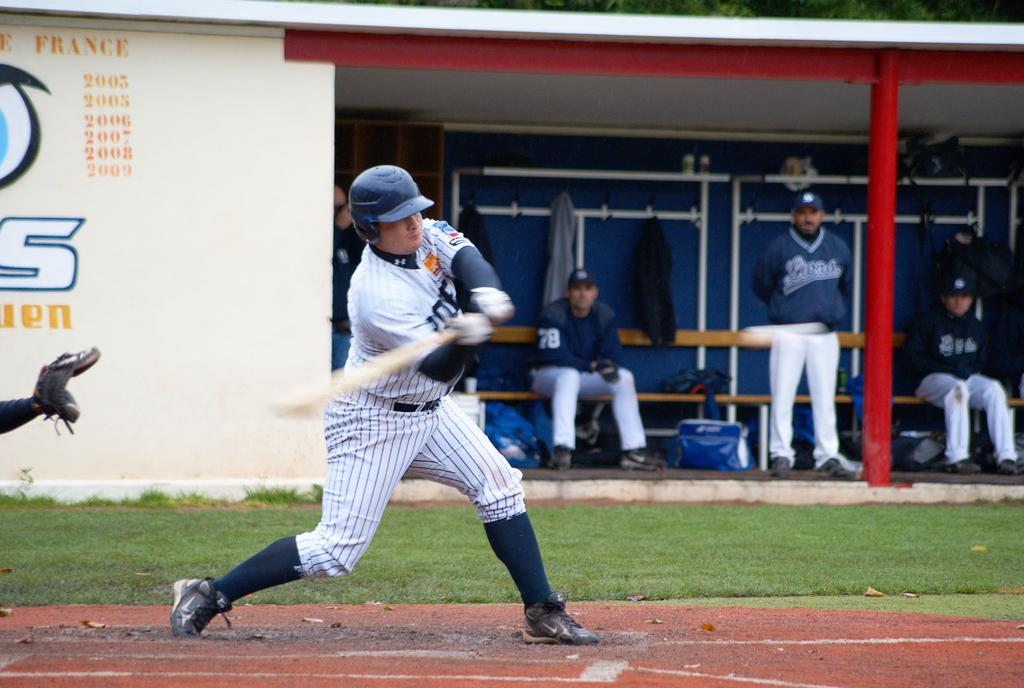<image>
Create a compact narrative representing the image presented. A batter is swinging with a wall that is labeled France 2003 2005 2006 2007 2008 2009 